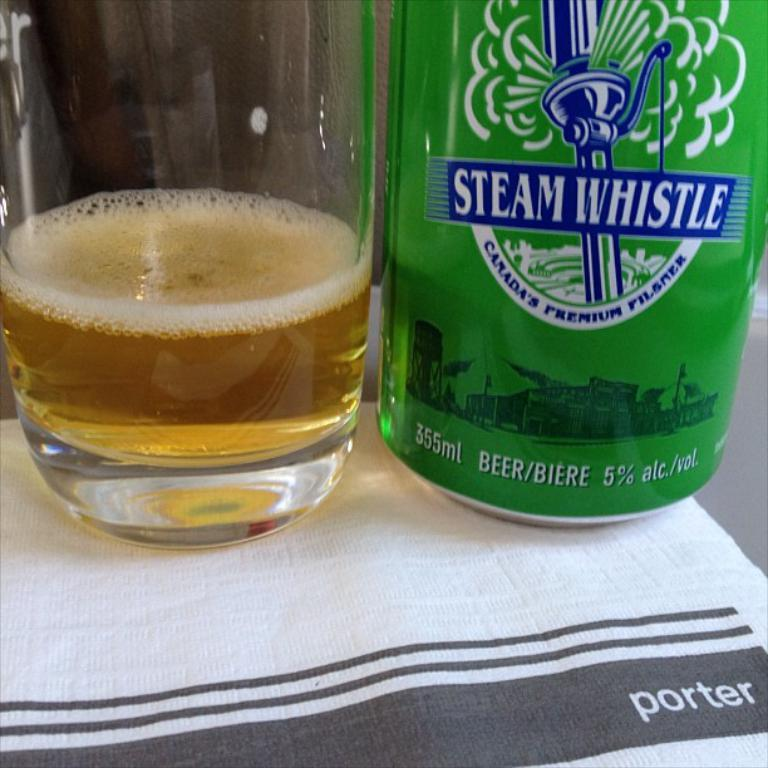<image>
Offer a succinct explanation of the picture presented. A glass of beer sitting next to a bottle of Steam Whistle 